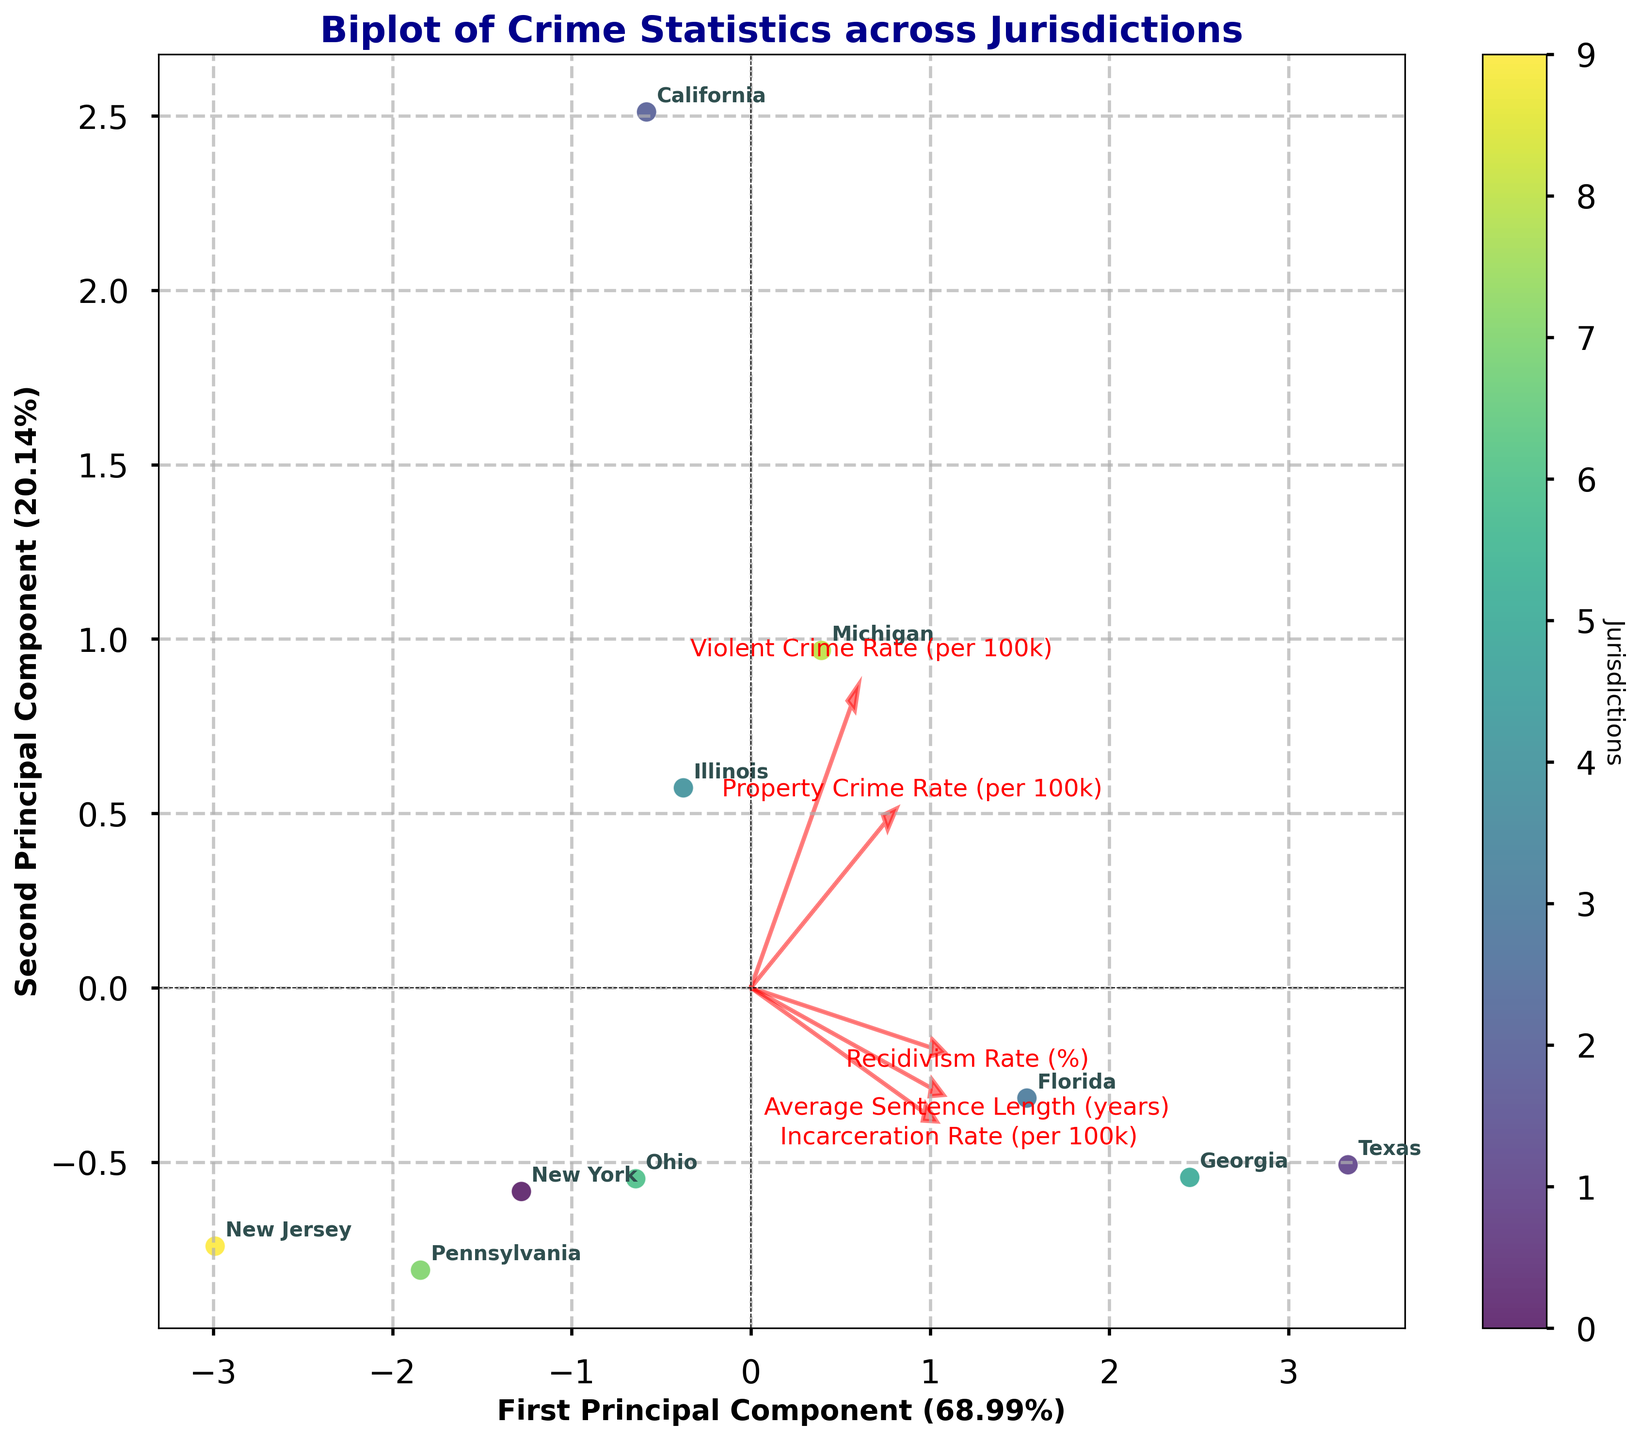What is the title of the plot? The title of the plot is displayed prominently at the top, indicating what the plot is about. It reads "Biplot of Crime Statistics across Jurisdictions".
Answer: Biplot of Crime Statistics across Jurisdictions How many principal components are shown on the axes? The labels of the two axes indicate the principal components; they read "First Principal Component" and "Second Principal Component". This implies two principal components are shown.
Answer: Two Which jurisdiction is most closely associated with high values of "Property Crime Rate (per 100k)"? The farthest arrow pointing towards "Property Crime Rate (per 100k)" should align with jurisdictions with high property crime rates. California's position near the direction of this arrow indicates it is closely associated with high property crime rates.
Answer: California Which jurisdiction appears to have the shortest average sentence length? The endpoint of the arrow for "Average Sentence Length (years)" indicates the direction of smaller values for that metric. New Jersey appears closer to the low end of this arrow, suggesting shorter sentences.
Answer: New Jersey How much variance is explained by the first principal component? The label on the x-axis for the First Principal Component indicates the explained variance in percentage. The x-axis label reads "First Principal Component (XX%)".
Answer: ~XX% (replace with actual percentage from data) Which jurisdictions form a cluster away from the others? By visually inspecting the scatter plot, two jurisdictions that may cluster away from others can be identified. Ohio and Pennsylvania appear closely positioned together and farther from other jurisdictions.
Answer: Ohio and Pennsylvania In terms of the second principal component, which jurisdiction has the greatest negative score? By observing the position along the y-axis representing the second principal component, New Jersey appears to have the lowest or most negative score.
Answer: New Jersey Which crime statistic is the most positively correlated with "Recidivism Rate (%)"? The direction and proximity of arrows relative to each other indicate correlation. "Incarceration Rate (per 100k)" seems to point in a similar direction to "Recidivism Rate (%)", suggesting positive correlation.
Answer: Incarceration Rate (per 100k) Which jurisdiction has the highest score on the first principal component? Examining the position on the horizontal axis representing the first principal component, Texas appears to have the highest score.
Answer: Texas Which jurisdiction has a high score on the second principal component but a low score on the first principal component? By checking the positions within the scatter plot, both scores on the two principal components indicate Michigan has high on the second component but relatively low on the first component.
Answer: Michigan 